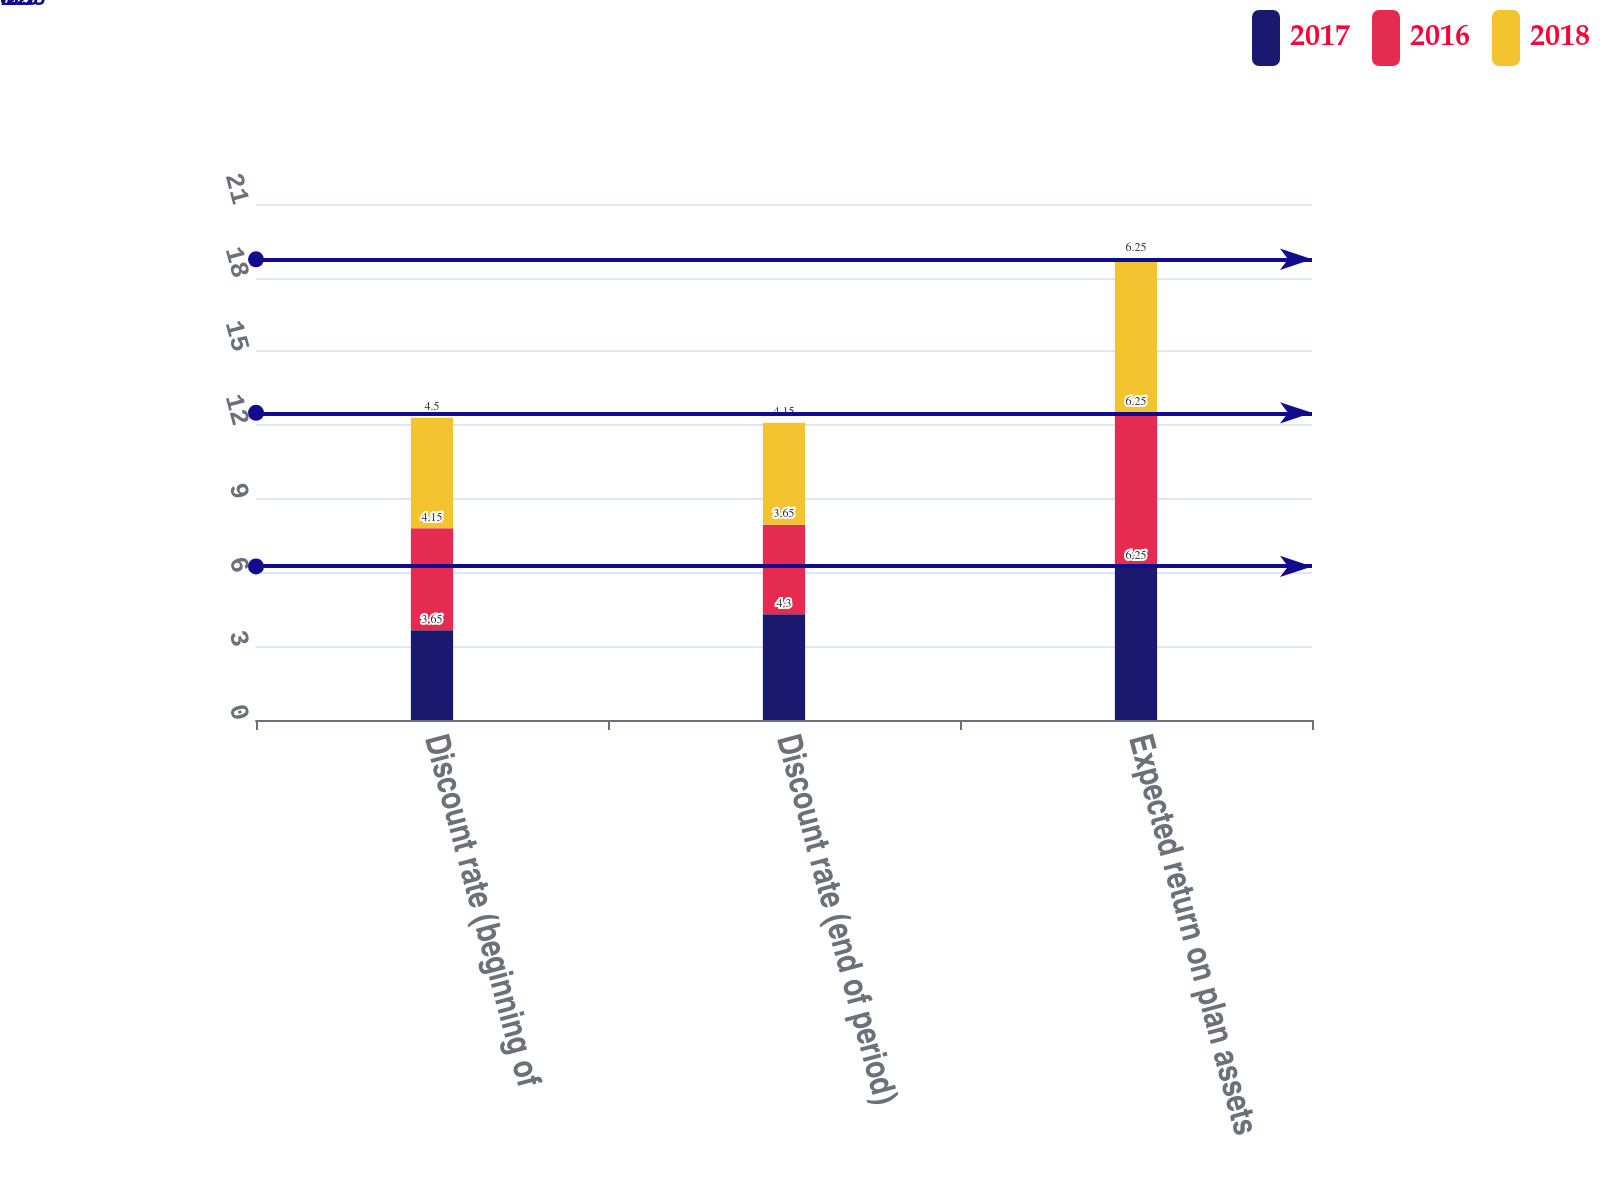<chart> <loc_0><loc_0><loc_500><loc_500><stacked_bar_chart><ecel><fcel>Discount rate (beginning of<fcel>Discount rate (end of period)<fcel>Expected return on plan assets<nl><fcel>2017<fcel>3.65<fcel>4.3<fcel>6.25<nl><fcel>2016<fcel>4.15<fcel>3.65<fcel>6.25<nl><fcel>2018<fcel>4.5<fcel>4.15<fcel>6.25<nl></chart> 